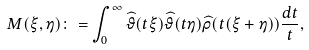Convert formula to latex. <formula><loc_0><loc_0><loc_500><loc_500>M ( \xi , \eta ) \colon = \int _ { 0 } ^ { \infty } \widehat { \vartheta } ( t \xi ) \widehat { \vartheta } ( t \eta ) \widehat { \rho } ( t ( \xi + \eta ) ) \frac { d t } { t } ,</formula> 